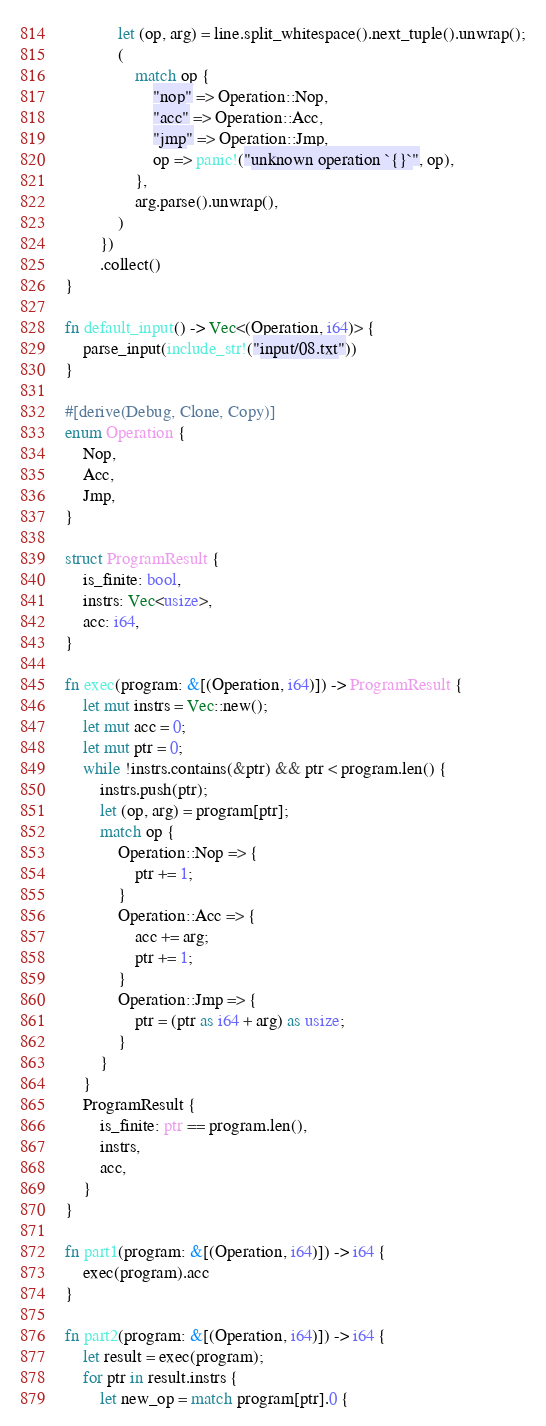Convert code to text. <code><loc_0><loc_0><loc_500><loc_500><_Rust_>            let (op, arg) = line.split_whitespace().next_tuple().unwrap();
            (
                match op {
                    "nop" => Operation::Nop,
                    "acc" => Operation::Acc,
                    "jmp" => Operation::Jmp,
                    op => panic!("unknown operation `{}`", op),
                },
                arg.parse().unwrap(),
            )
        })
        .collect()
}

fn default_input() -> Vec<(Operation, i64)> {
    parse_input(include_str!("input/08.txt"))
}

#[derive(Debug, Clone, Copy)]
enum Operation {
    Nop,
    Acc,
    Jmp,
}

struct ProgramResult {
    is_finite: bool,
    instrs: Vec<usize>,
    acc: i64,
}

fn exec(program: &[(Operation, i64)]) -> ProgramResult {
    let mut instrs = Vec::new();
    let mut acc = 0;
    let mut ptr = 0;
    while !instrs.contains(&ptr) && ptr < program.len() {
        instrs.push(ptr);
        let (op, arg) = program[ptr];
        match op {
            Operation::Nop => {
                ptr += 1;
            }
            Operation::Acc => {
                acc += arg;
                ptr += 1;
            }
            Operation::Jmp => {
                ptr = (ptr as i64 + arg) as usize;
            }
        }
    }
    ProgramResult {
        is_finite: ptr == program.len(),
        instrs,
        acc,
    }
}

fn part1(program: &[(Operation, i64)]) -> i64 {
    exec(program).acc
}

fn part2(program: &[(Operation, i64)]) -> i64 {
    let result = exec(program);
    for ptr in result.instrs {
        let new_op = match program[ptr].0 {</code> 